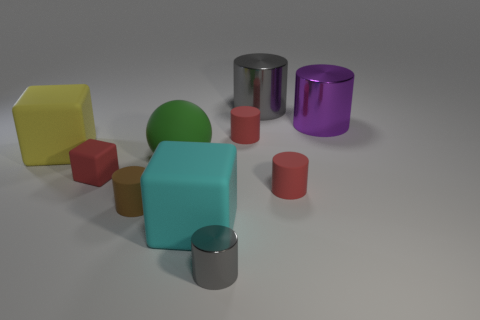What can be inferred about the light source in this image based on the shadows? The shadows in the image are soft and diffuse, suggesting the light source is not very intense or is perhaps diffused by a translucent cover. The shadows also hint that the light source is located to the top left of the scene, as indicated by the direction of the shadows stretching towards the bottom right. 